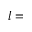<formula> <loc_0><loc_0><loc_500><loc_500>l =</formula> 